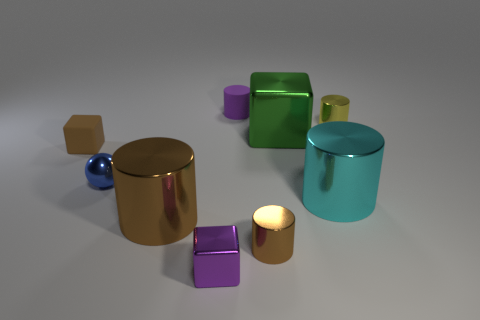There is a shiny object that is behind the metal sphere and in front of the small yellow metallic object; what is its color?
Offer a terse response. Green. There is a purple metallic cube; what number of tiny objects are in front of it?
Offer a very short reply. 0. What number of things are either rubber things or cubes in front of the blue object?
Make the answer very short. 3. There is a tiny metallic cylinder that is left of the small yellow thing; is there a tiny purple cube in front of it?
Your answer should be compact. Yes. There is a metallic thing that is behind the big green metal block; what color is it?
Make the answer very short. Yellow. Are there an equal number of tiny blue metallic objects behind the rubber block and metallic spheres?
Make the answer very short. No. The small metal thing that is both behind the big cyan metal cylinder and in front of the large cube has what shape?
Ensure brevity in your answer.  Sphere. The tiny matte object that is the same shape as the tiny yellow metal thing is what color?
Your answer should be very brief. Purple. Are there any other things of the same color as the small matte block?
Provide a short and direct response. Yes. What is the shape of the small purple object that is behind the big cylinder that is on the right side of the purple object in front of the brown cube?
Offer a terse response. Cylinder. 